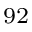<formula> <loc_0><loc_0><loc_500><loc_500>^ { 9 2 }</formula> 